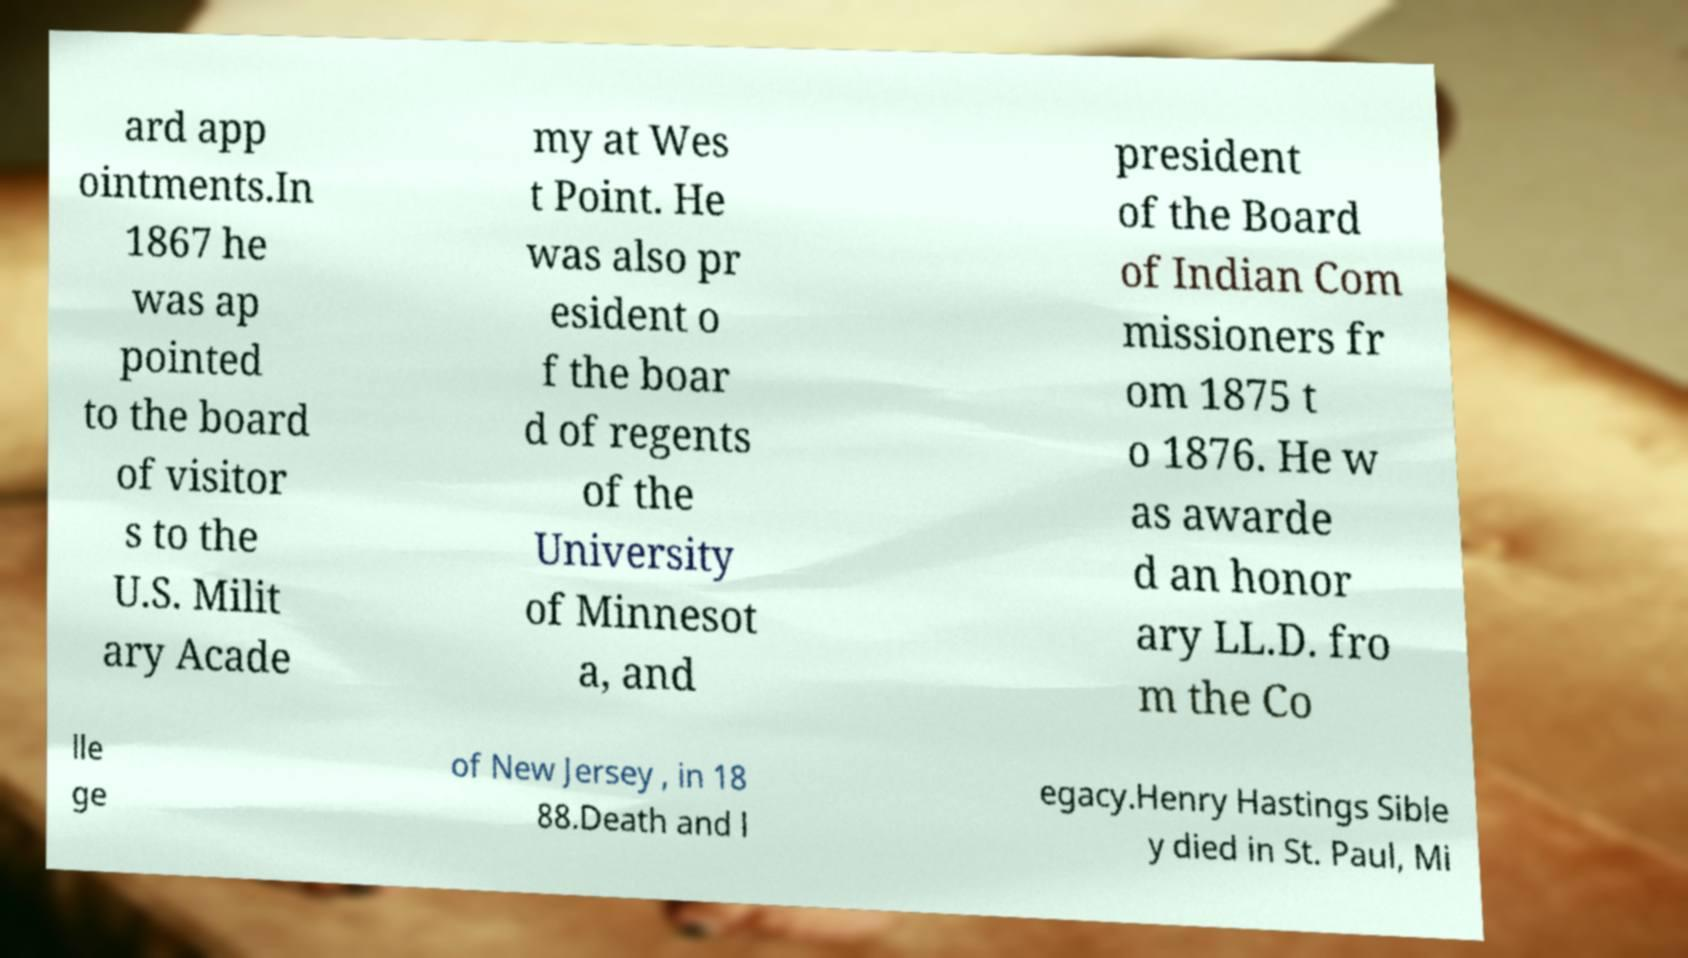Please identify and transcribe the text found in this image. ard app ointments.In 1867 he was ap pointed to the board of visitor s to the U.S. Milit ary Acade my at Wes t Point. He was also pr esident o f the boar d of regents of the University of Minnesot a, and president of the Board of Indian Com missioners fr om 1875 t o 1876. He w as awarde d an honor ary LL.D. fro m the Co lle ge of New Jersey , in 18 88.Death and l egacy.Henry Hastings Sible y died in St. Paul, Mi 